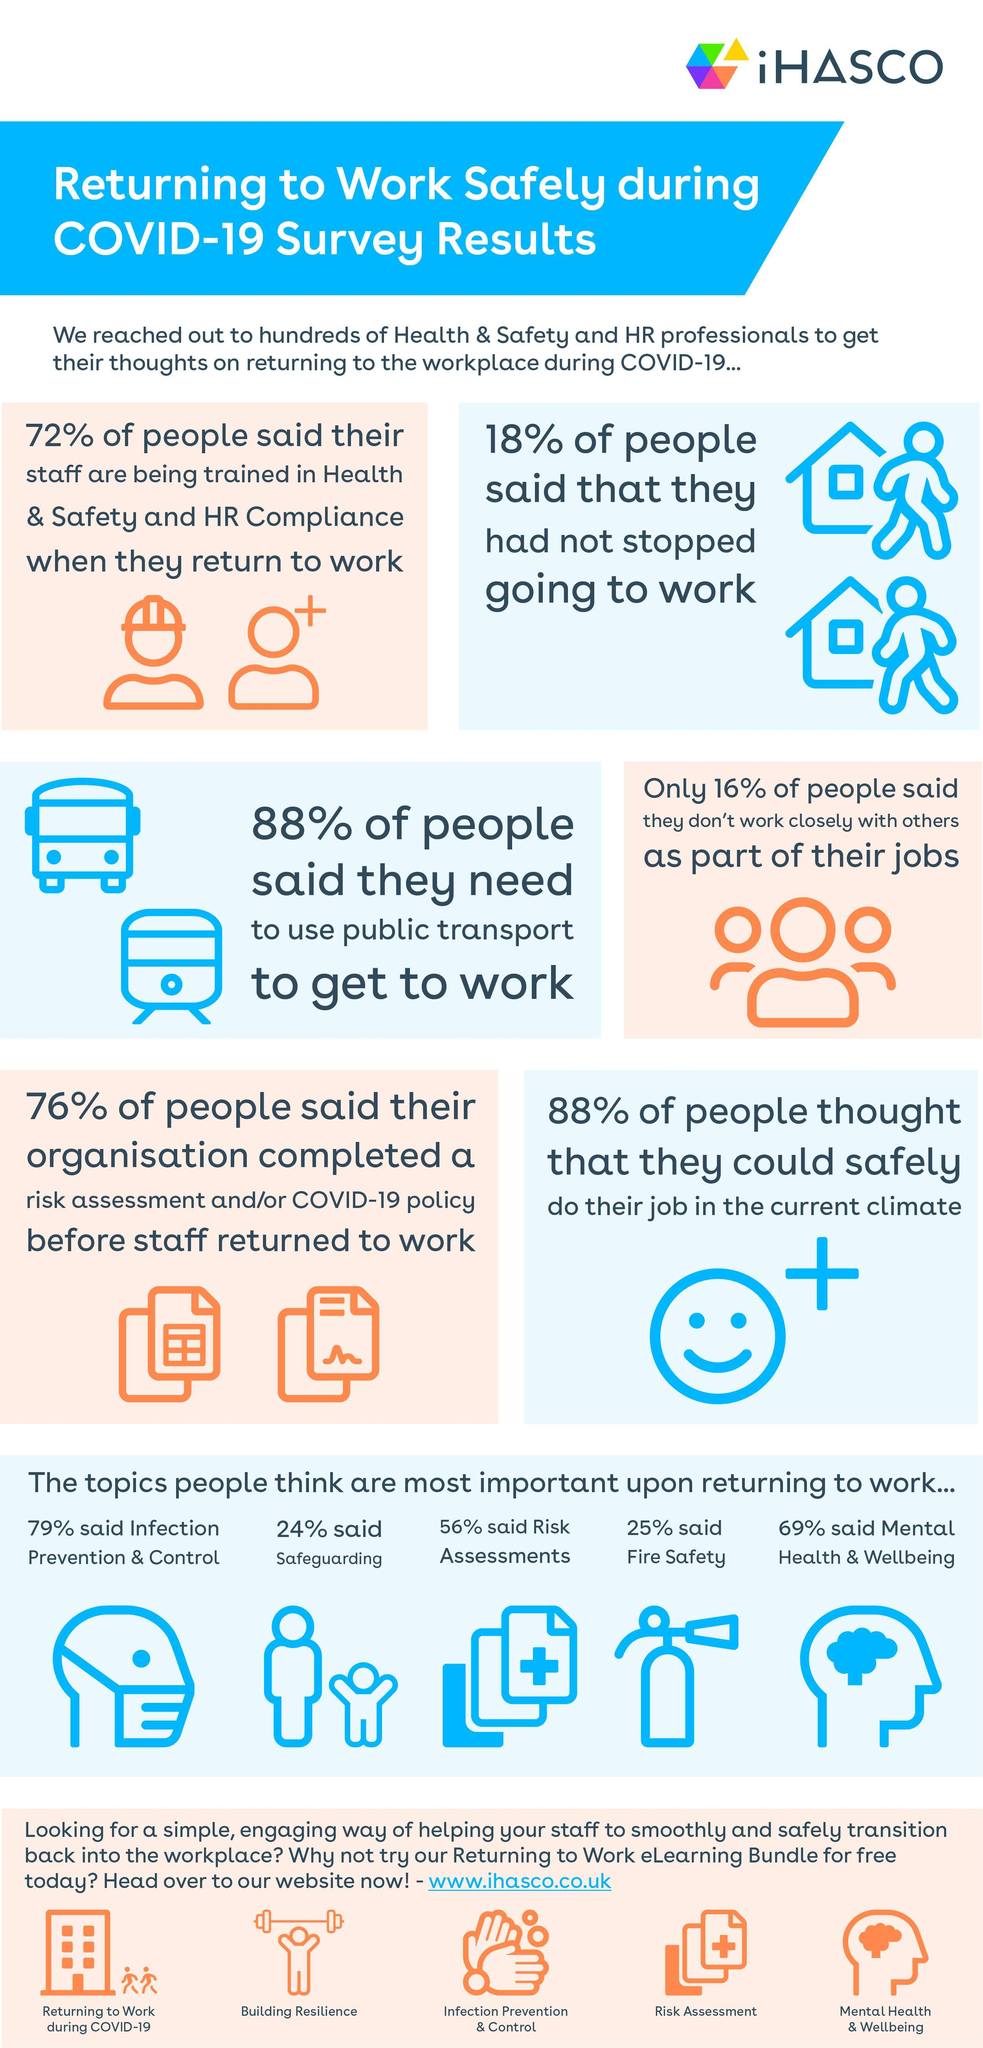What percent of Health & Safety and HR Professionals stopped going to work?
Answer the question with a short phrase. 82% What percent of people do not need to use public transport? 12% What is the topic that is most important to a majority of people? Infection Prevention & Control 